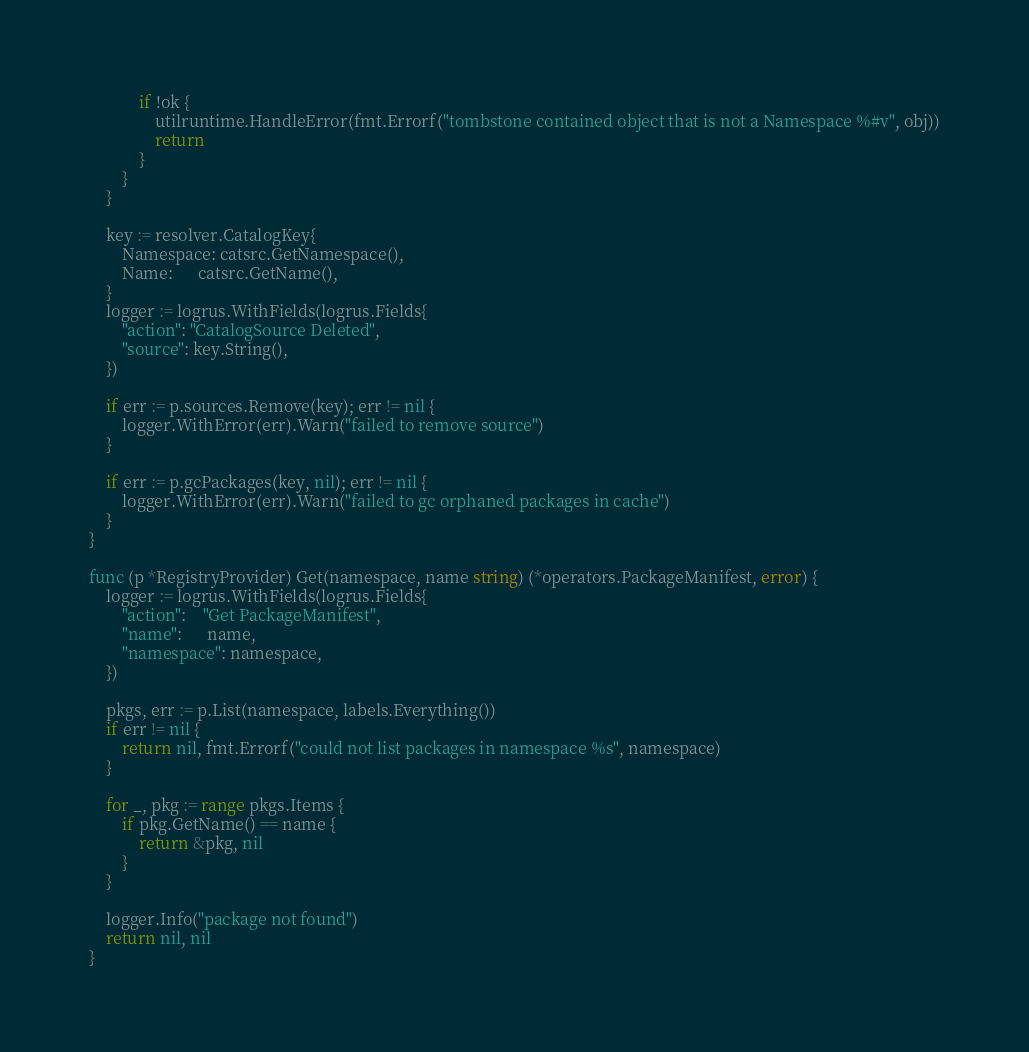<code> <loc_0><loc_0><loc_500><loc_500><_Go_>			if !ok {
				utilruntime.HandleError(fmt.Errorf("tombstone contained object that is not a Namespace %#v", obj))
				return
			}
		}
	}

	key := resolver.CatalogKey{
		Namespace: catsrc.GetNamespace(),
		Name:      catsrc.GetName(),
	}
	logger := logrus.WithFields(logrus.Fields{
		"action": "CatalogSource Deleted",
		"source": key.String(),
	})

	if err := p.sources.Remove(key); err != nil {
		logger.WithError(err).Warn("failed to remove source")
	}

	if err := p.gcPackages(key, nil); err != nil {
		logger.WithError(err).Warn("failed to gc orphaned packages in cache")
	}
}

func (p *RegistryProvider) Get(namespace, name string) (*operators.PackageManifest, error) {
	logger := logrus.WithFields(logrus.Fields{
		"action":    "Get PackageManifest",
		"name":      name,
		"namespace": namespace,
	})

	pkgs, err := p.List(namespace, labels.Everything())
	if err != nil {
		return nil, fmt.Errorf("could not list packages in namespace %s", namespace)
	}

	for _, pkg := range pkgs.Items {
		if pkg.GetName() == name {
			return &pkg, nil
		}
	}

	logger.Info("package not found")
	return nil, nil
}
</code> 